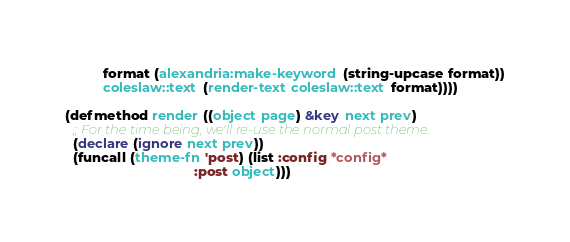Convert code to text. <code><loc_0><loc_0><loc_500><loc_500><_Lisp_>          format (alexandria:make-keyword (string-upcase format))
          coleslaw::text (render-text coleslaw::text format))))

(defmethod render ((object page) &key next prev)
  ;; For the time being, we'll re-use the normal post theme.
  (declare (ignore next prev))
  (funcall (theme-fn 'post) (list :config *config*
                                  :post object)))
</code> 